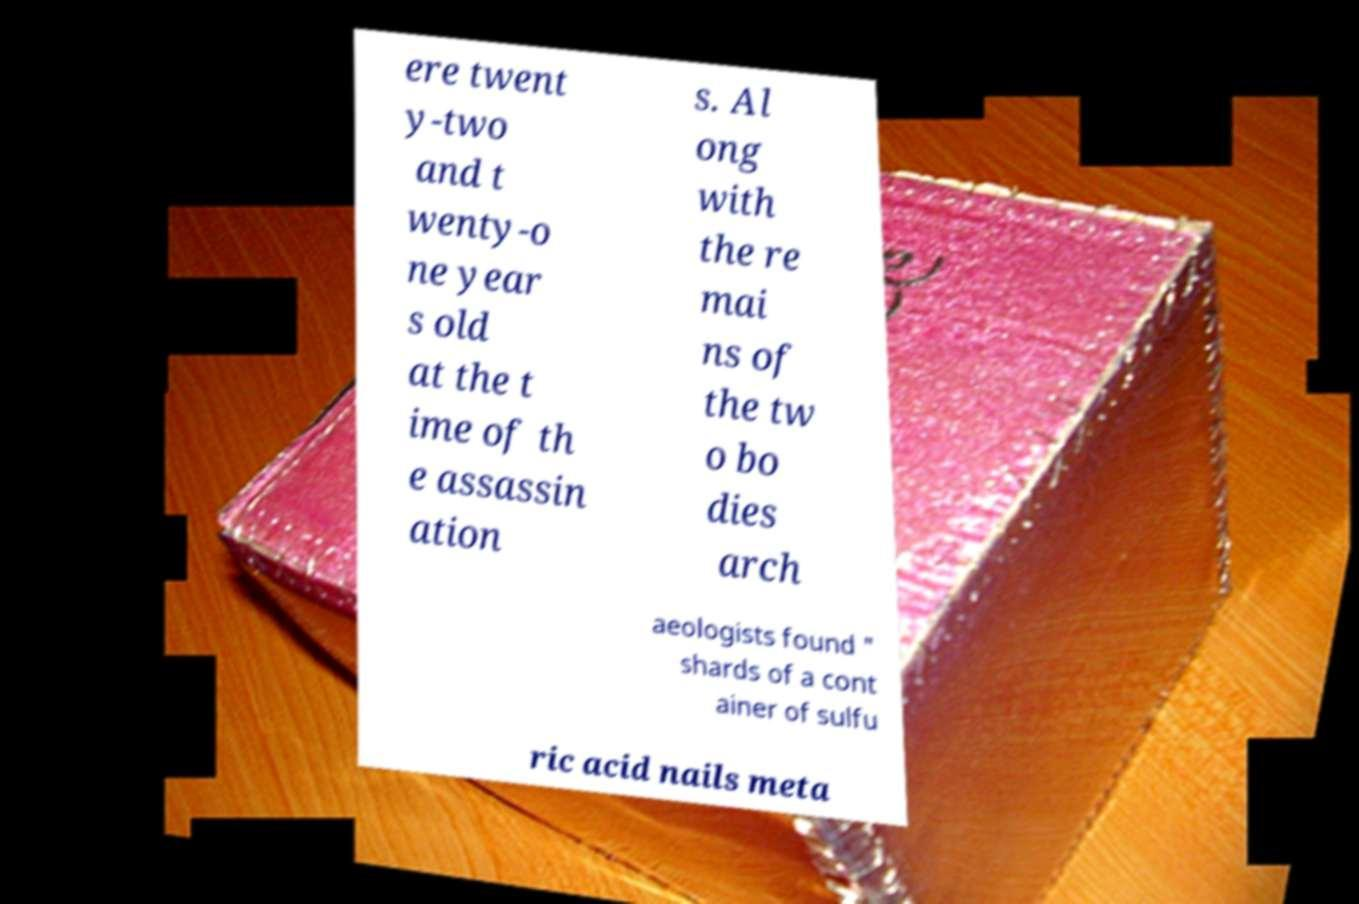I need the written content from this picture converted into text. Can you do that? ere twent y-two and t wenty-o ne year s old at the t ime of th e assassin ation s. Al ong with the re mai ns of the tw o bo dies arch aeologists found " shards of a cont ainer of sulfu ric acid nails meta 